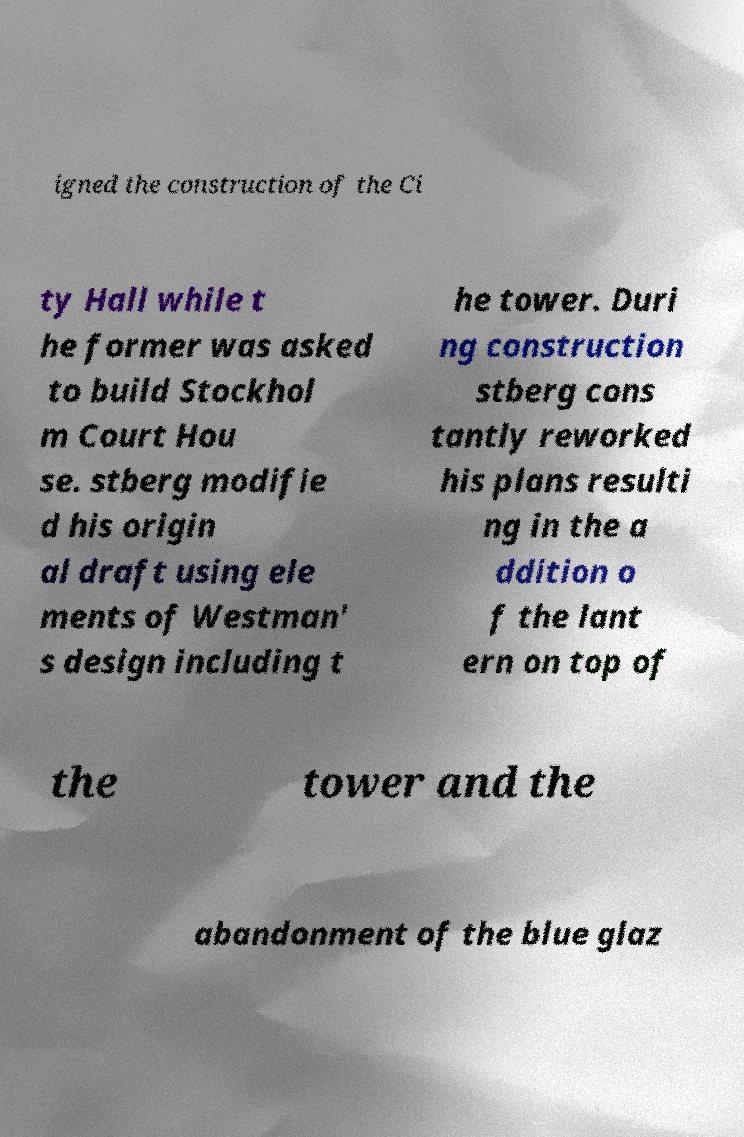Can you accurately transcribe the text from the provided image for me? igned the construction of the Ci ty Hall while t he former was asked to build Stockhol m Court Hou se. stberg modifie d his origin al draft using ele ments of Westman' s design including t he tower. Duri ng construction stberg cons tantly reworked his plans resulti ng in the a ddition o f the lant ern on top of the tower and the abandonment of the blue glaz 